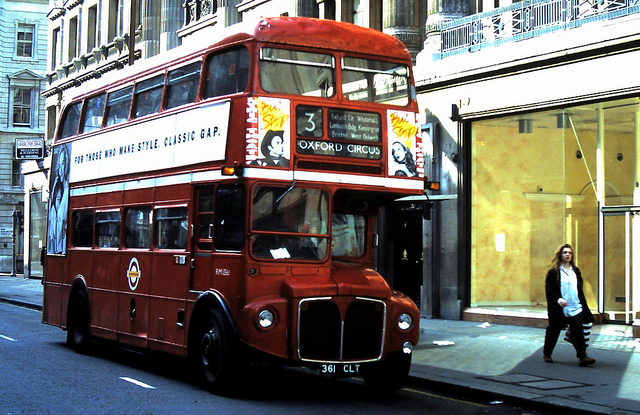Read all the text in this image. GAP CLASSIC 3 CIRCUS STYLE CLT 361 Bw SET 